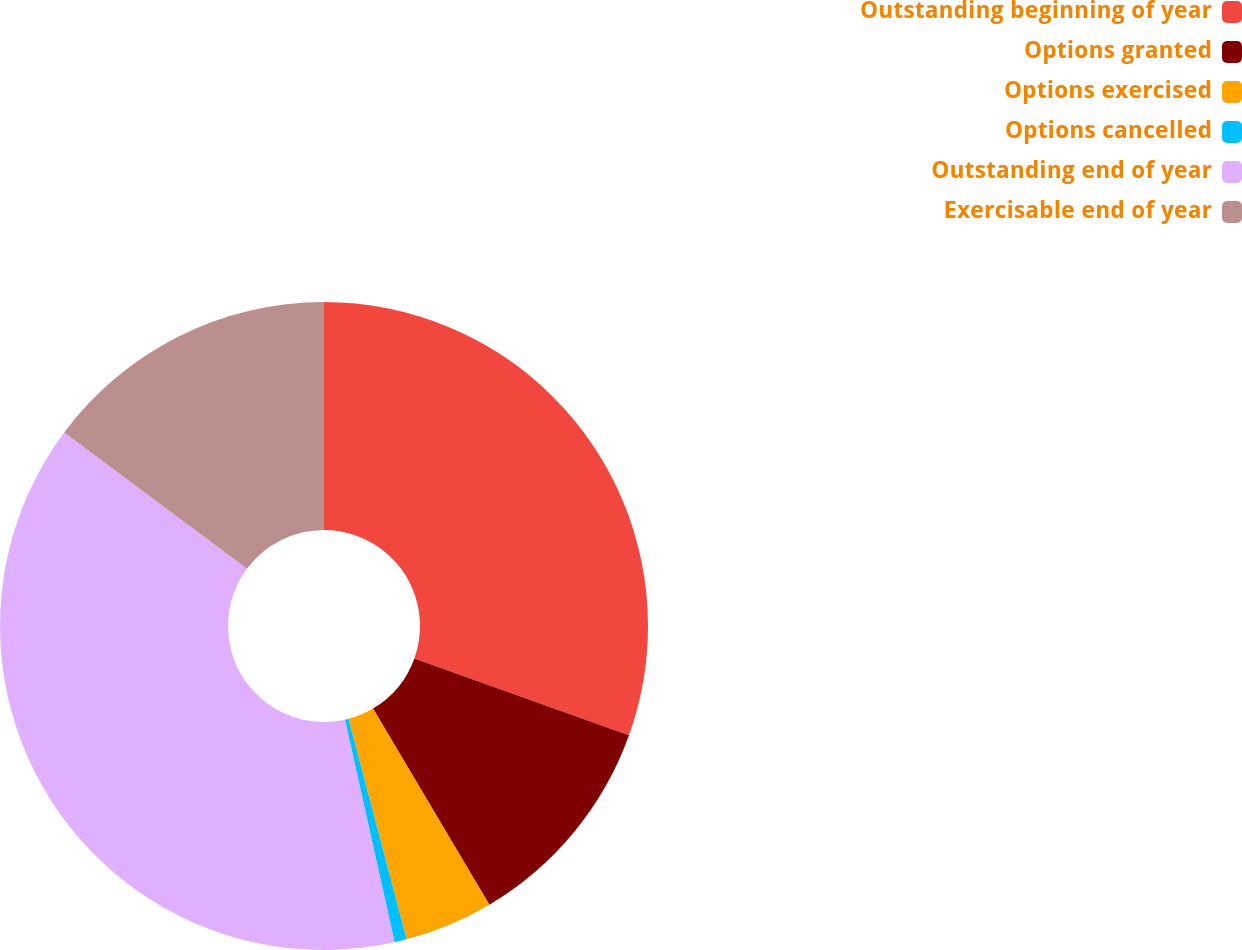Convert chart. <chart><loc_0><loc_0><loc_500><loc_500><pie_chart><fcel>Outstanding beginning of year<fcel>Options granted<fcel>Options exercised<fcel>Options cancelled<fcel>Outstanding end of year<fcel>Exercisable end of year<nl><fcel>30.48%<fcel>11.0%<fcel>4.42%<fcel>0.61%<fcel>38.69%<fcel>14.81%<nl></chart> 